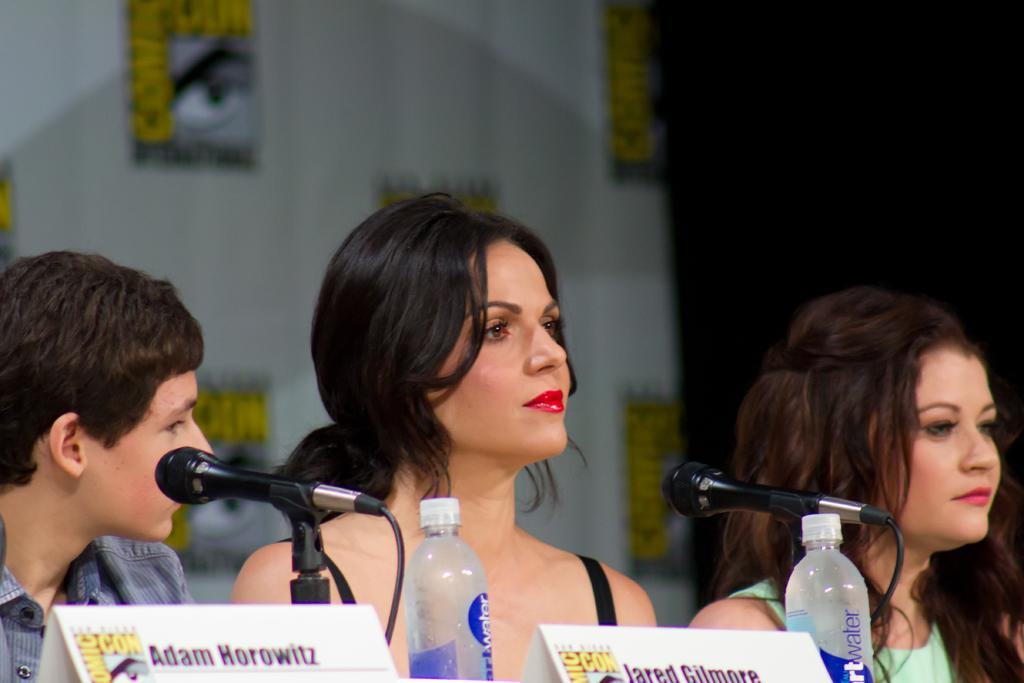How many people are in the image? There are two men in the image. What is one of the men doing in the image? One man is sitting in front of a table. What object is present in the image that is typically used for eating or working on? There is a table in the image. What object is on the table that is typically used for amplifying sound? There is a microphone on the table. What type of jelly is being used to fix the pest problem in the image? There is no jelly or pest problem present in the image. How many cubs are visible in the image? There are no cubs present in the image. 